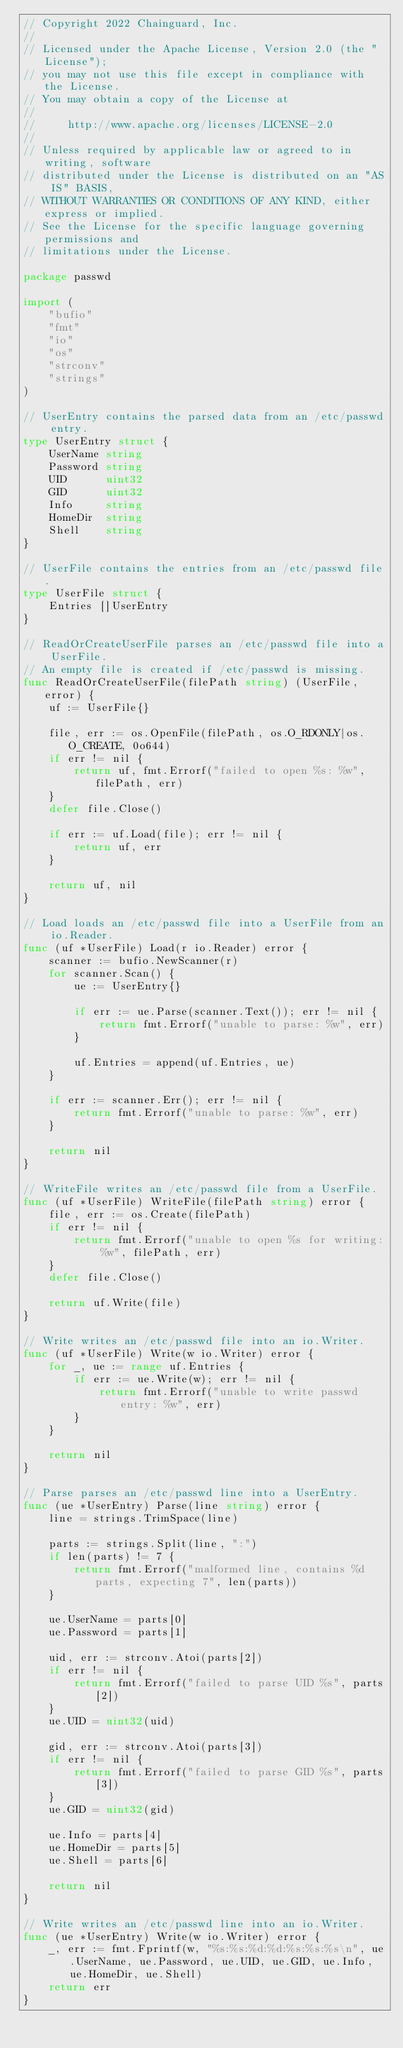<code> <loc_0><loc_0><loc_500><loc_500><_Go_>// Copyright 2022 Chainguard, Inc.
//
// Licensed under the Apache License, Version 2.0 (the "License");
// you may not use this file except in compliance with the License.
// You may obtain a copy of the License at
//
//     http://www.apache.org/licenses/LICENSE-2.0
//
// Unless required by applicable law or agreed to in writing, software
// distributed under the License is distributed on an "AS IS" BASIS,
// WITHOUT WARRANTIES OR CONDITIONS OF ANY KIND, either express or implied.
// See the License for the specific language governing permissions and
// limitations under the License.

package passwd

import (
	"bufio"
	"fmt"
	"io"
	"os"
	"strconv"
	"strings"
)

// UserEntry contains the parsed data from an /etc/passwd entry.
type UserEntry struct {
	UserName string
	Password string
	UID      uint32
	GID      uint32
	Info     string
	HomeDir  string
	Shell    string
}

// UserFile contains the entries from an /etc/passwd file.
type UserFile struct {
	Entries []UserEntry
}

// ReadOrCreateUserFile parses an /etc/passwd file into a UserFile.
// An empty file is created if /etc/passwd is missing.
func ReadOrCreateUserFile(filePath string) (UserFile, error) {
	uf := UserFile{}

	file, err := os.OpenFile(filePath, os.O_RDONLY|os.O_CREATE, 0o644)
	if err != nil {
		return uf, fmt.Errorf("failed to open %s: %w", filePath, err)
	}
	defer file.Close()

	if err := uf.Load(file); err != nil {
		return uf, err
	}

	return uf, nil
}

// Load loads an /etc/passwd file into a UserFile from an io.Reader.
func (uf *UserFile) Load(r io.Reader) error {
	scanner := bufio.NewScanner(r)
	for scanner.Scan() {
		ue := UserEntry{}

		if err := ue.Parse(scanner.Text()); err != nil {
			return fmt.Errorf("unable to parse: %w", err)
		}

		uf.Entries = append(uf.Entries, ue)
	}

	if err := scanner.Err(); err != nil {
		return fmt.Errorf("unable to parse: %w", err)
	}

	return nil
}

// WriteFile writes an /etc/passwd file from a UserFile.
func (uf *UserFile) WriteFile(filePath string) error {
	file, err := os.Create(filePath)
	if err != nil {
		return fmt.Errorf("unable to open %s for writing: %w", filePath, err)
	}
	defer file.Close()

	return uf.Write(file)
}

// Write writes an /etc/passwd file into an io.Writer.
func (uf *UserFile) Write(w io.Writer) error {
	for _, ue := range uf.Entries {
		if err := ue.Write(w); err != nil {
			return fmt.Errorf("unable to write passwd entry: %w", err)
		}
	}

	return nil
}

// Parse parses an /etc/passwd line into a UserEntry.
func (ue *UserEntry) Parse(line string) error {
	line = strings.TrimSpace(line)

	parts := strings.Split(line, ":")
	if len(parts) != 7 {
		return fmt.Errorf("malformed line, contains %d parts, expecting 7", len(parts))
	}

	ue.UserName = parts[0]
	ue.Password = parts[1]

	uid, err := strconv.Atoi(parts[2])
	if err != nil {
		return fmt.Errorf("failed to parse UID %s", parts[2])
	}
	ue.UID = uint32(uid)

	gid, err := strconv.Atoi(parts[3])
	if err != nil {
		return fmt.Errorf("failed to parse GID %s", parts[3])
	}
	ue.GID = uint32(gid)

	ue.Info = parts[4]
	ue.HomeDir = parts[5]
	ue.Shell = parts[6]

	return nil
}

// Write writes an /etc/passwd line into an io.Writer.
func (ue *UserEntry) Write(w io.Writer) error {
	_, err := fmt.Fprintf(w, "%s:%s:%d:%d:%s:%s:%s\n", ue.UserName, ue.Password, ue.UID, ue.GID, ue.Info, ue.HomeDir, ue.Shell)
	return err
}
</code> 